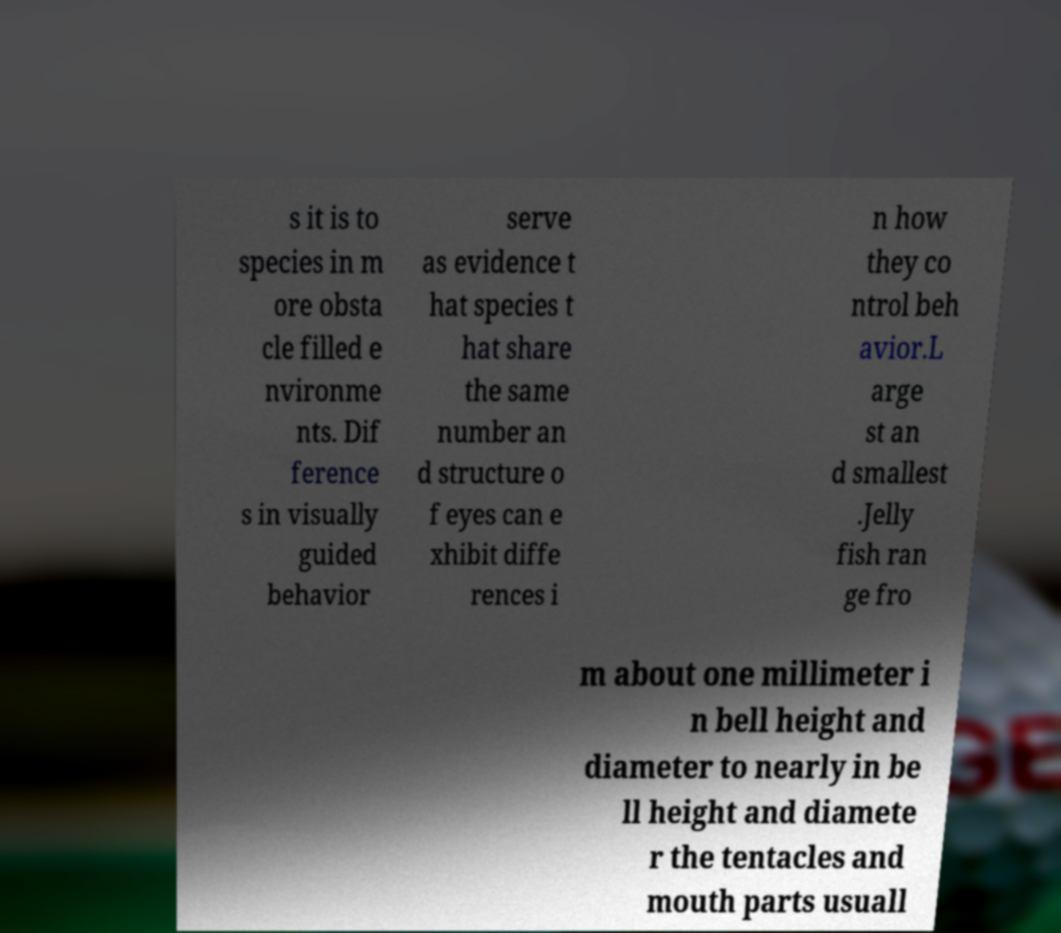I need the written content from this picture converted into text. Can you do that? s it is to species in m ore obsta cle filled e nvironme nts. Dif ference s in visually guided behavior serve as evidence t hat species t hat share the same number an d structure o f eyes can e xhibit diffe rences i n how they co ntrol beh avior.L arge st an d smallest .Jelly fish ran ge fro m about one millimeter i n bell height and diameter to nearly in be ll height and diamete r the tentacles and mouth parts usuall 